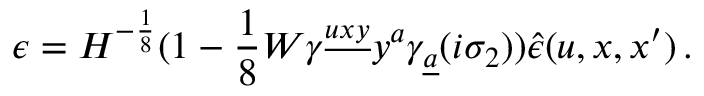<formula> <loc_0><loc_0><loc_500><loc_500>\epsilon = H ^ { - { \frac { 1 } { 8 } } } ( 1 - { \frac { 1 } { 8 } } W \gamma ^ { \underline { u x y } } y ^ { a } \gamma _ { \underline { a } } ( i \sigma _ { 2 } ) ) \hat { \epsilon } ( u , x , x ^ { \prime } ) \, .</formula> 